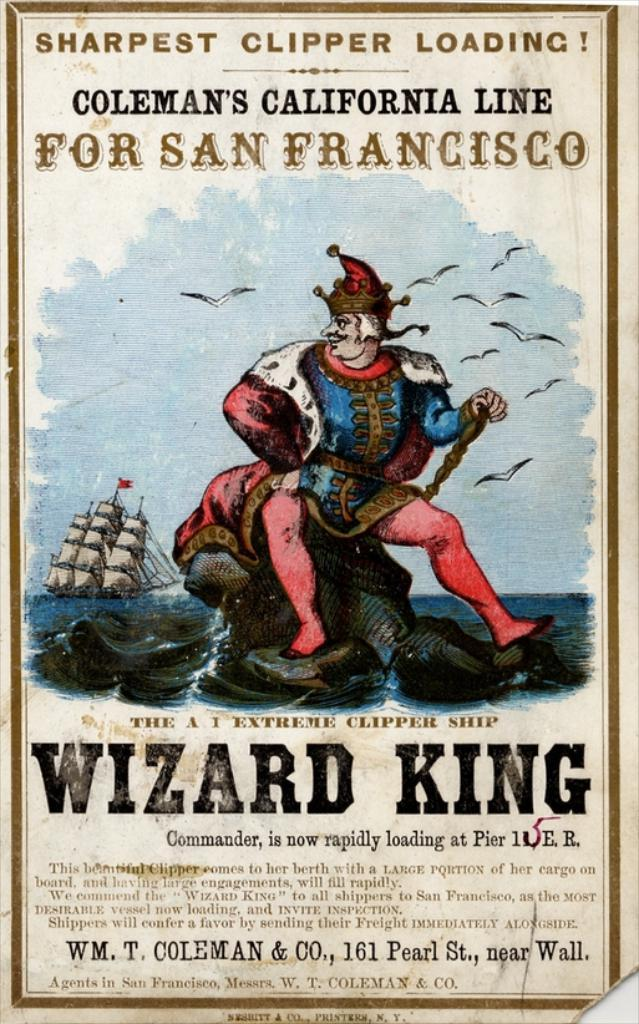<image>
Give a short and clear explanation of the subsequent image. a poster with the wizard king on it 